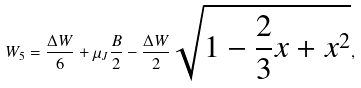Convert formula to latex. <formula><loc_0><loc_0><loc_500><loc_500>W _ { 5 } = \frac { \Delta W } { 6 } + \mu _ { J } \frac { B } { 2 } - \frac { \Delta W } { 2 } \sqrt { 1 - \frac { 2 } { 3 } x + x ^ { 2 } } ,</formula> 